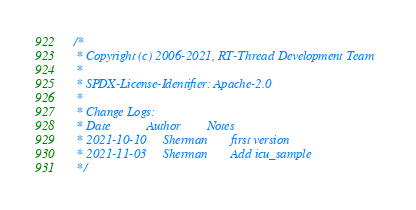Convert code to text. <code><loc_0><loc_0><loc_500><loc_500><_C_>/*
 * Copyright (c) 2006-2021, RT-Thread Development Team
 *
 * SPDX-License-Identifier: Apache-2.0
 *
 * Change Logs:
 * Date           Author        Notes
 * 2021-10-10     Sherman       first version
 * 2021-11-03     Sherman       Add icu_sample
 */
</code> 